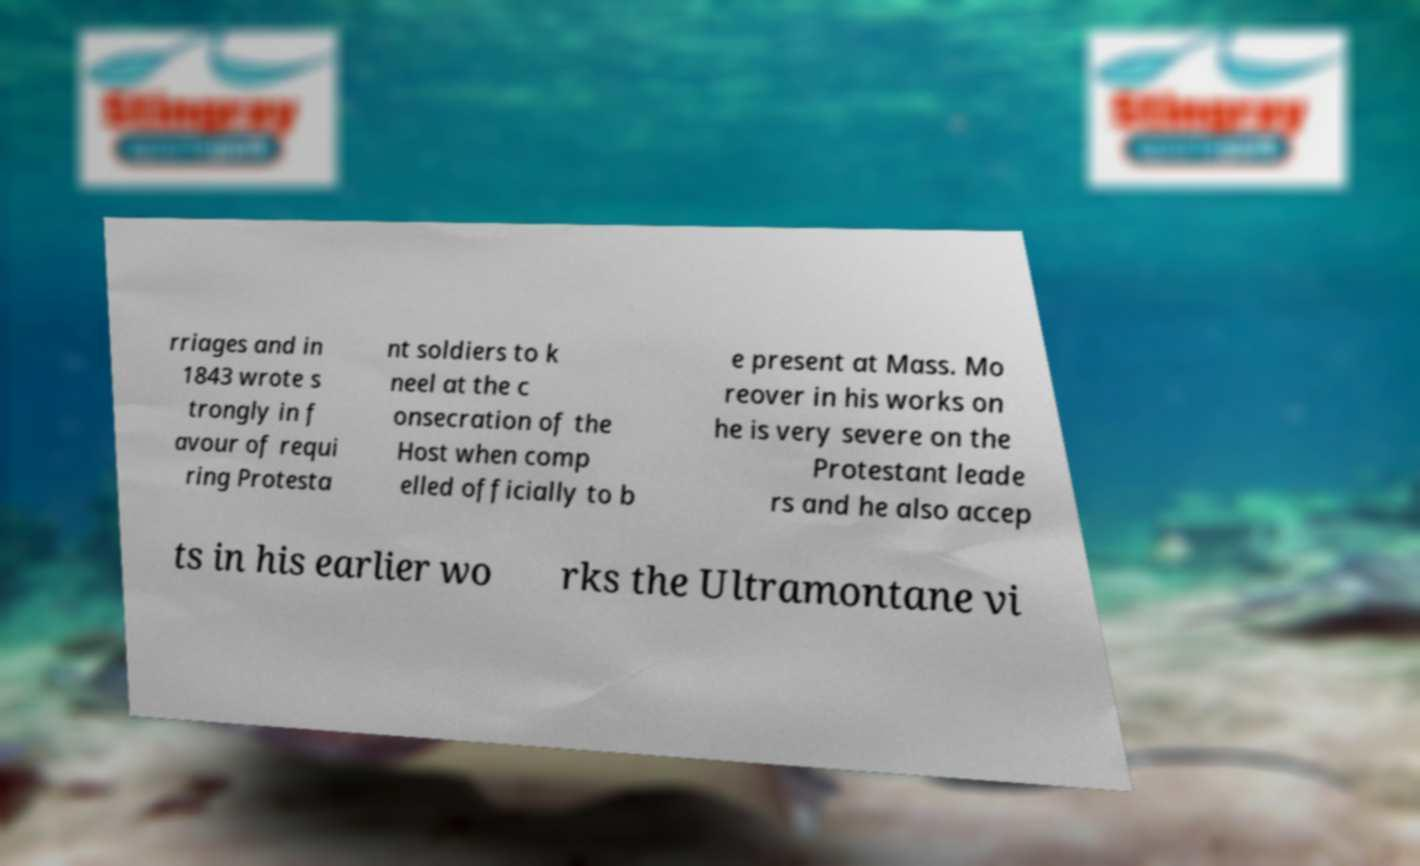Please read and relay the text visible in this image. What does it say? rriages and in 1843 wrote s trongly in f avour of requi ring Protesta nt soldiers to k neel at the c onsecration of the Host when comp elled officially to b e present at Mass. Mo reover in his works on he is very severe on the Protestant leade rs and he also accep ts in his earlier wo rks the Ultramontane vi 